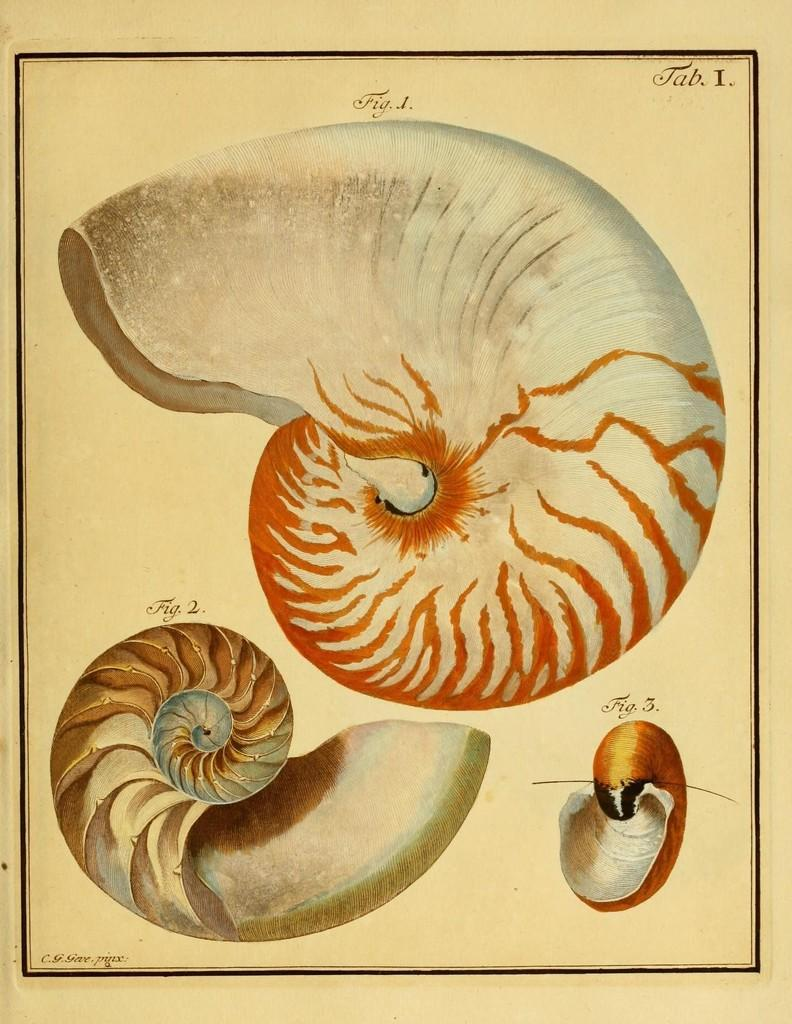What is the main subject of the image? There is a painting in the image. What can be seen within the painting? The painting contains figures. Can you tell me how many times the figure in the painting coils around itself? There is no information about the figure coiling around itself in the image. 